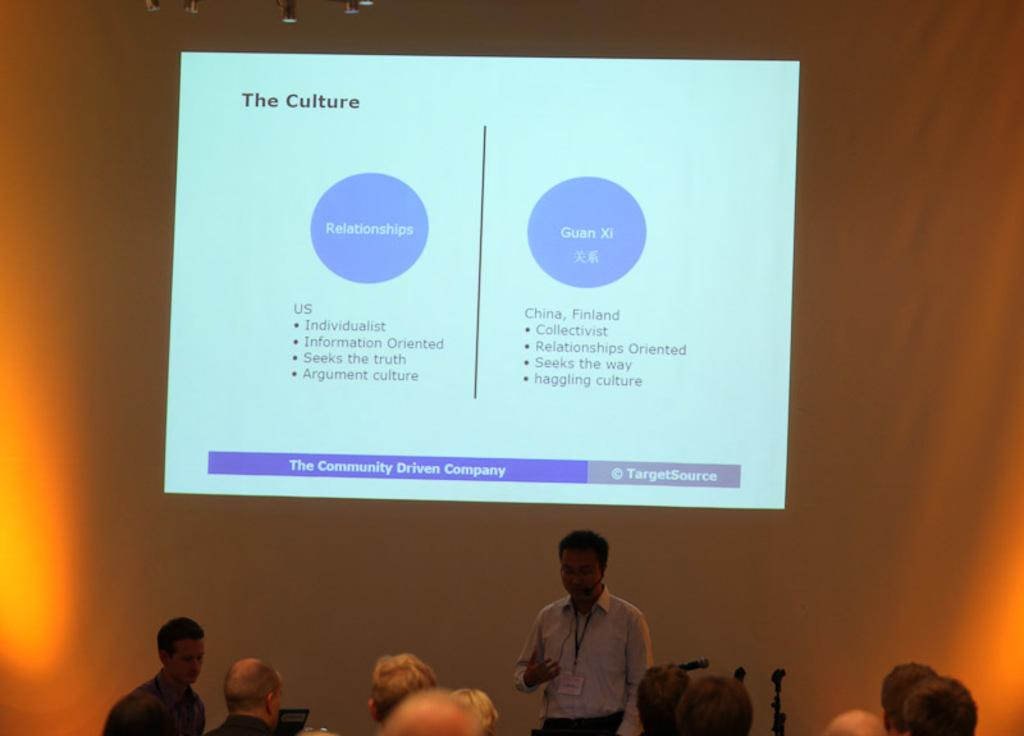Who or what can be seen in the image? There are people in the image. Can you describe the objects present in the image? There are objects in the bottom and top side of the image. What is visible in the background of the image? There is a screen visible in the background of the image. What type of neck accessory is worn by the people in the image? There is no information about neck accessories in the image, as the provided facts do not mention any. 